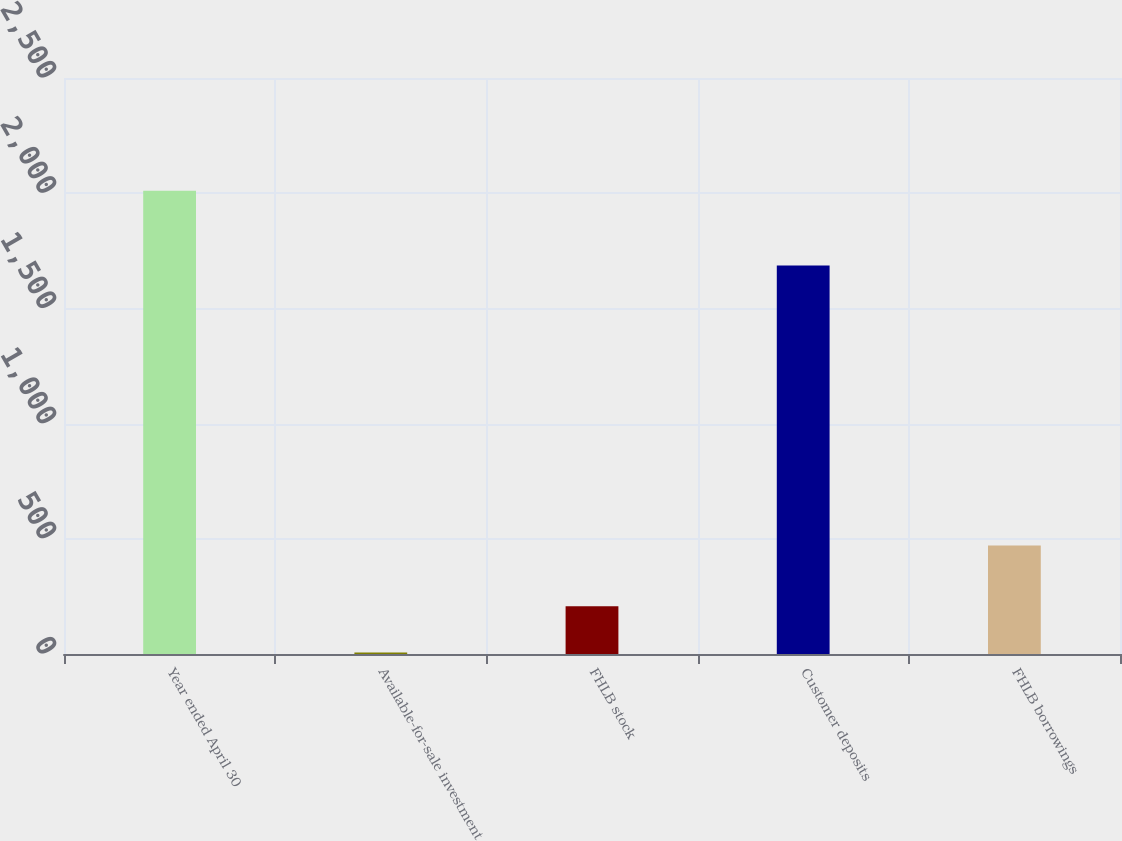<chart> <loc_0><loc_0><loc_500><loc_500><bar_chart><fcel>Year ended April 30<fcel>Available-for-sale investment<fcel>FHLB stock<fcel>Customer deposits<fcel>FHLB borrowings<nl><fcel>2011<fcel>7<fcel>207.4<fcel>1686<fcel>471<nl></chart> 